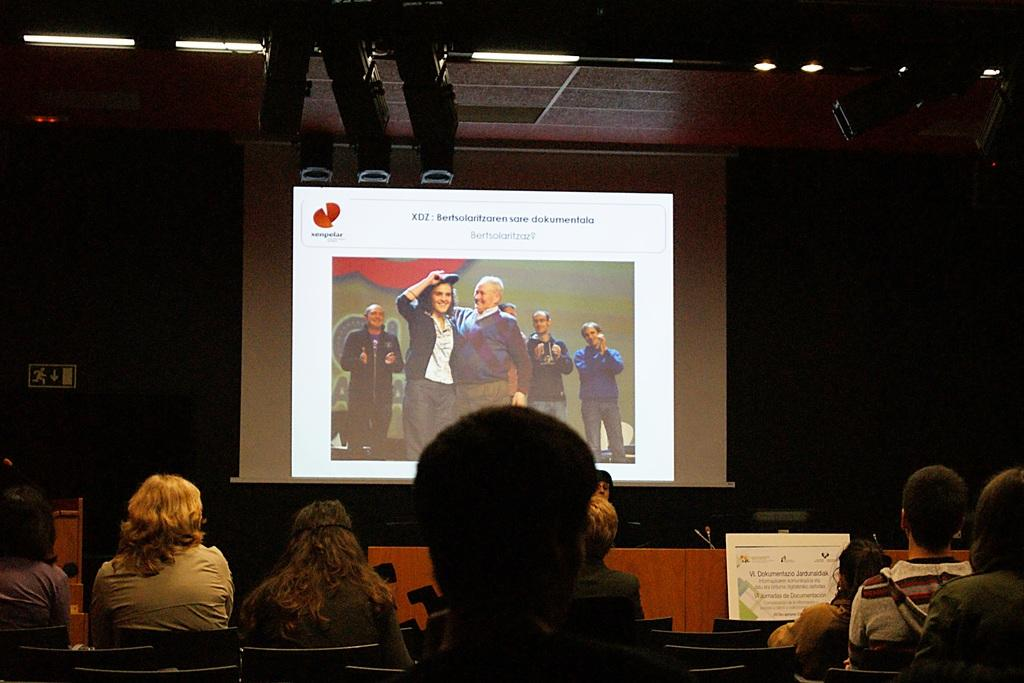What is the main subject in the foreground of the image? There is a person's head in the foreground of the image. What are the people in the background doing? The persons sitting on chairs in the background suggest they might be attending an event or gathering. What can be seen on the wall in the background? There is a screen visible in the background. What type of lighting is present in the background? There are lights on the ceiling in the background. How would you describe the overall lighting in the image? The background is dark, indicating that the lighting is dim or low. Can you tell me how many yaks are visible in the image? There are no yaks present in the image. What type of crate is being used to store the rule in the image? There is no crate or rule present in the image. 